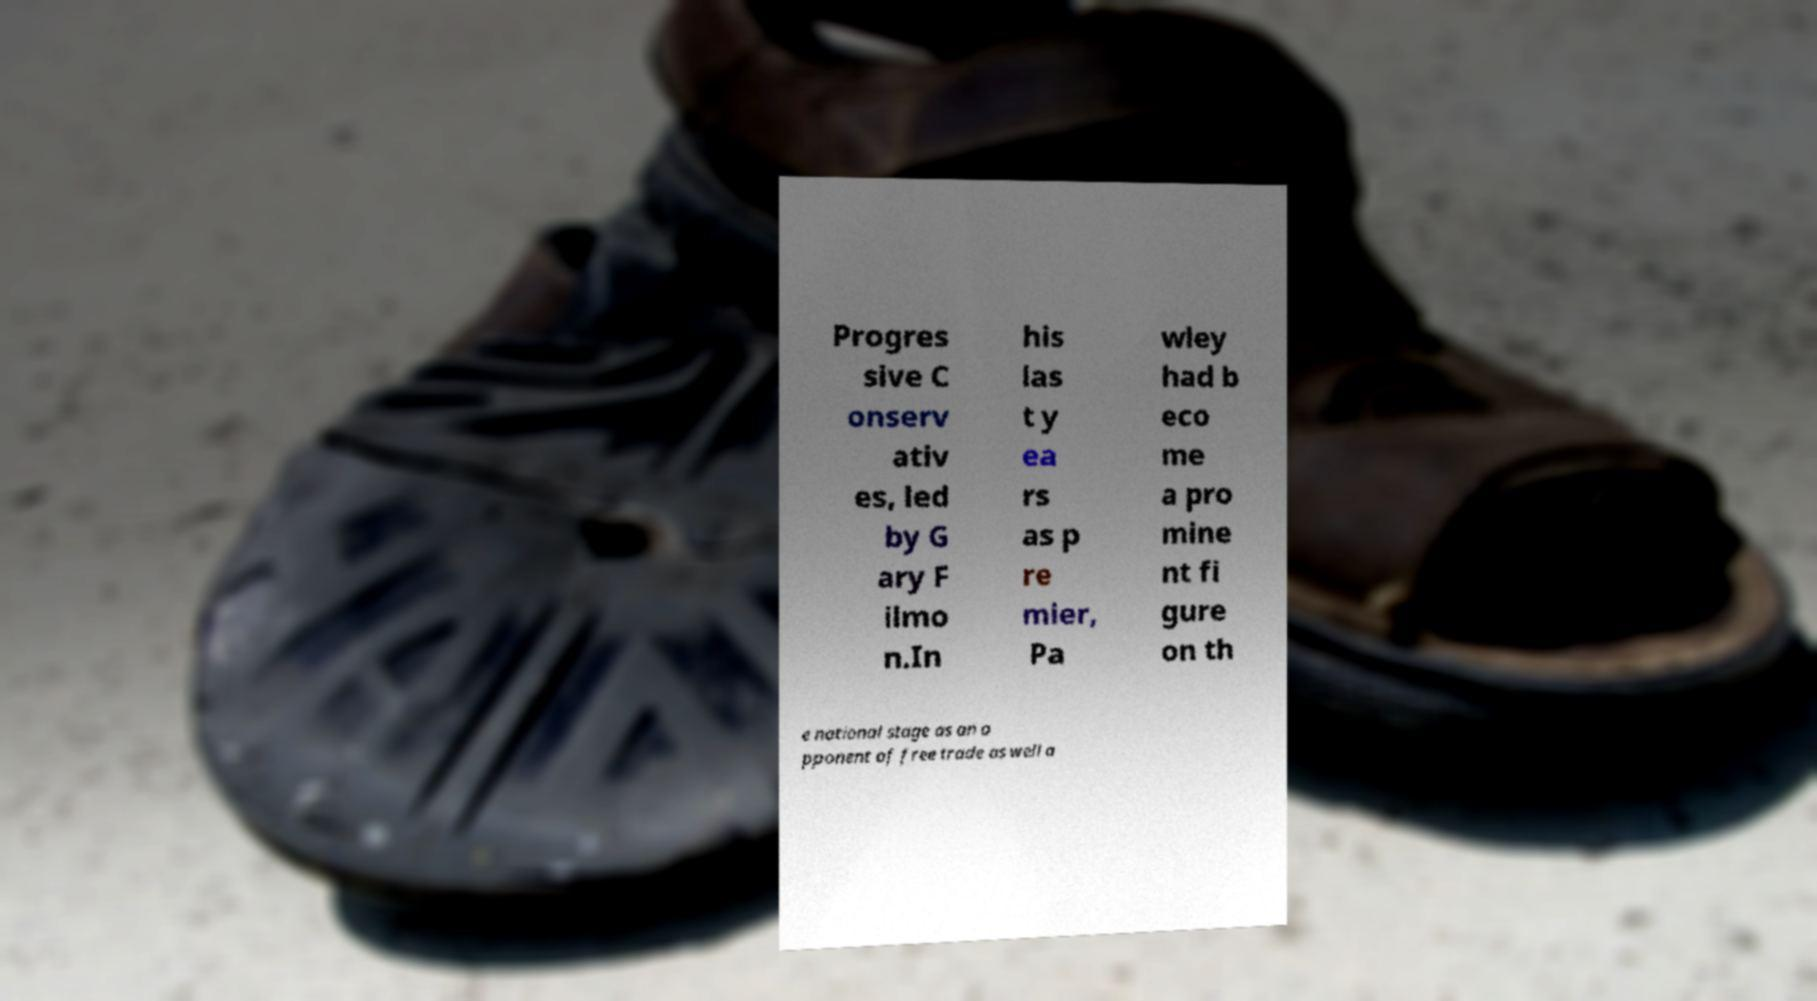Please read and relay the text visible in this image. What does it say? Progres sive C onserv ativ es, led by G ary F ilmo n.In his las t y ea rs as p re mier, Pa wley had b eco me a pro mine nt fi gure on th e national stage as an o pponent of free trade as well a 